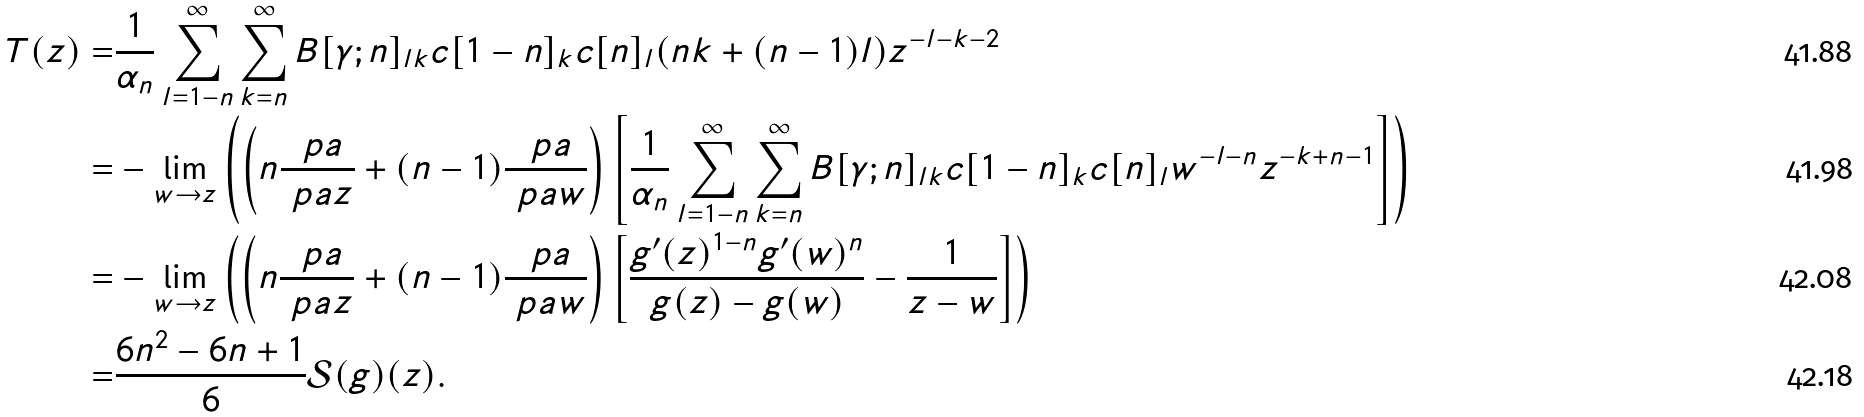<formula> <loc_0><loc_0><loc_500><loc_500>T ( z ) = & \frac { 1 } { \alpha _ { n } } \sum _ { l = 1 - n } ^ { \infty } \sum _ { k = n } ^ { \infty } B [ \gamma ; n ] _ { l k } c [ 1 - n ] _ { k } c [ n ] _ { l } ( n k + ( n - 1 ) l ) z ^ { - l - k - 2 } \\ = & - \lim _ { w \rightarrow z } \left ( \left ( n \frac { \ p a } { \ p a z } + ( n - 1 ) \frac { \ p a } { \ p a w } \right ) \left [ \frac { 1 } { \alpha _ { n } } \sum _ { l = 1 - n } ^ { \infty } \sum _ { k = n } ^ { \infty } B [ \gamma ; n ] _ { l k } c [ 1 - n ] _ { k } c [ n ] _ { l } w ^ { - l - n } z ^ { - k + n - 1 } \right ] \right ) \\ = & - \lim _ { w \rightarrow z } \left ( \left ( n \frac { \ p a } { \ p a z } + ( n - 1 ) \frac { \ p a } { \ p a w } \right ) \left [ \frac { g ^ { \prime } ( z ) ^ { 1 - n } g ^ { \prime } ( w ) ^ { n } } { g ( z ) - g ( w ) } - \frac { 1 } { z - w } \right ] \right ) \\ = & \frac { 6 n ^ { 2 } - 6 n + 1 } { 6 } \mathcal { S } ( g ) ( z ) .</formula> 